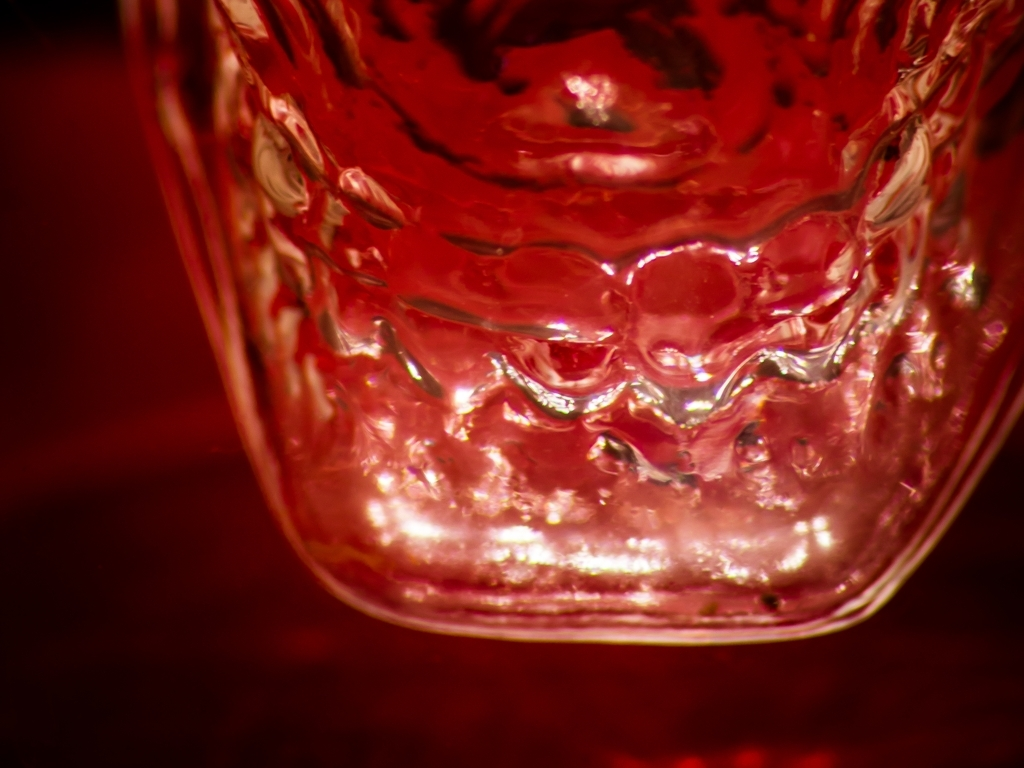What could be the use of the object pictured here? This object appears to be a glass vessel of some sort, likely a decorative item designed to hold liquids. Its aesthetic implies it might be used for special occasions or as part of a formal table setting. 